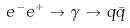<formula> <loc_0><loc_0><loc_500><loc_500>e ^ { - } e ^ { + } \to \gamma \to q { \bar { q } }</formula> 